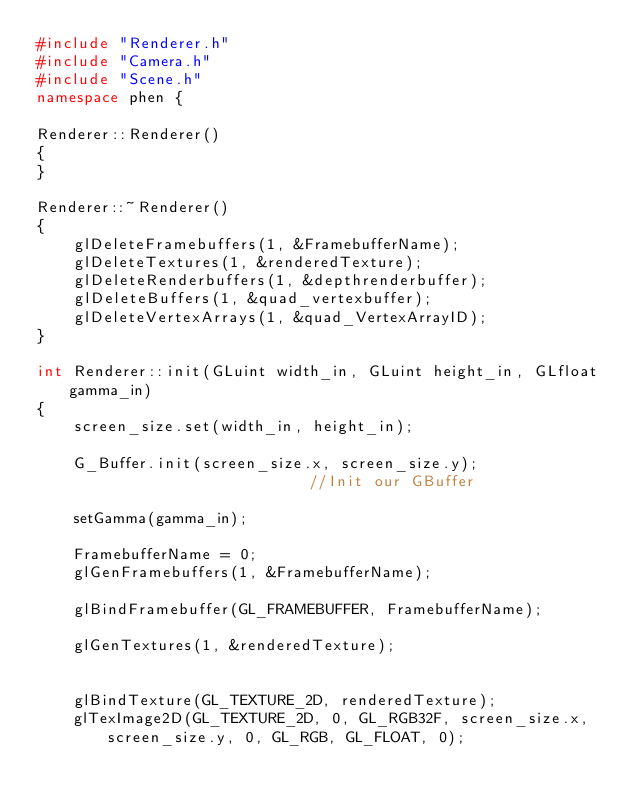Convert code to text. <code><loc_0><loc_0><loc_500><loc_500><_C++_>#include "Renderer.h"
#include "Camera.h"
#include "Scene.h"
namespace phen {

Renderer::Renderer()
{
}

Renderer::~Renderer()
{
    glDeleteFramebuffers(1, &FramebufferName);
    glDeleteTextures(1, &renderedTexture);
    glDeleteRenderbuffers(1, &depthrenderbuffer);
    glDeleteBuffers(1, &quad_vertexbuffer);
    glDeleteVertexArrays(1, &quad_VertexArrayID);
}

int Renderer::init(GLuint width_in, GLuint height_in, GLfloat gamma_in)
{
    screen_size.set(width_in, height_in);

    G_Buffer.init(screen_size.x, screen_size.y);                       //Init our GBuffer

    setGamma(gamma_in);

    FramebufferName = 0;
    glGenFramebuffers(1, &FramebufferName);

    glBindFramebuffer(GL_FRAMEBUFFER, FramebufferName);

    glGenTextures(1, &renderedTexture);


    glBindTexture(GL_TEXTURE_2D, renderedTexture);
    glTexImage2D(GL_TEXTURE_2D, 0, GL_RGB32F, screen_size.x, screen_size.y, 0, GL_RGB, GL_FLOAT, 0);
</code> 